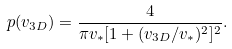<formula> <loc_0><loc_0><loc_500><loc_500>p ( v _ { 3 D } ) = \frac { 4 } { \pi v _ { * } [ 1 + ( v _ { 3 D } / v _ { * } ) ^ { 2 } ] ^ { 2 } } .</formula> 